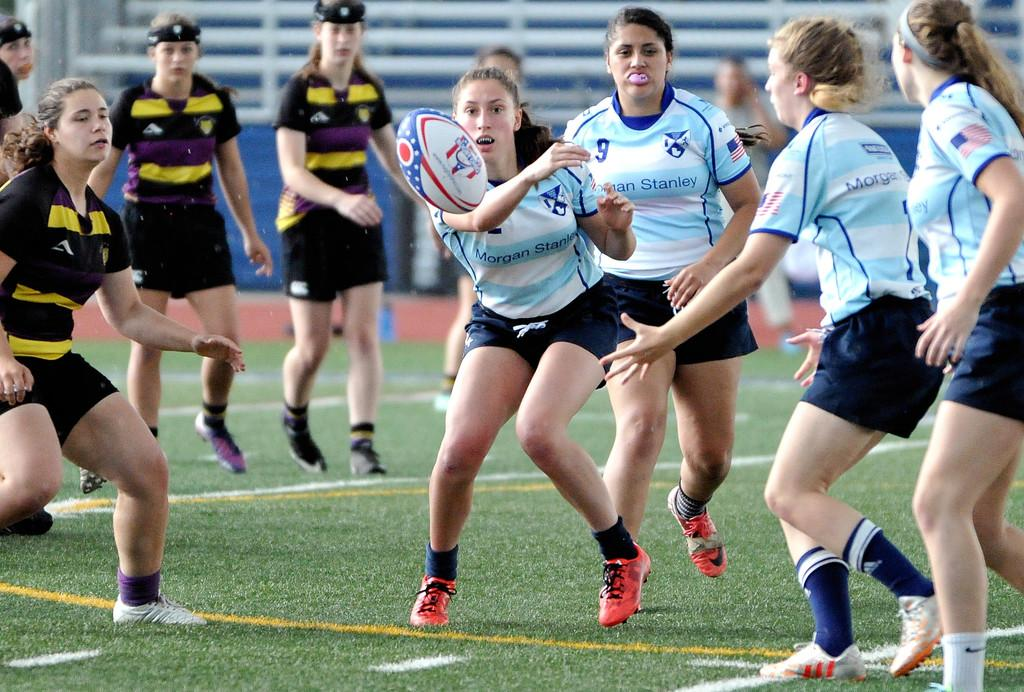Who is present in the image? There are girls in the image. What are the girls wearing? The girls are wearing black dresses and blue t-shirts. What is happening in the image? There is a ball in the air, and the girls are playing a game on the ground. What is the daughter teaching the girls in the image? There is no daughter present in the image, and therefore no teaching can be observed. 